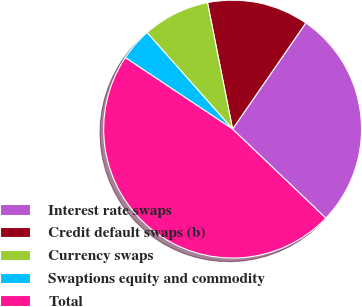Convert chart to OTSL. <chart><loc_0><loc_0><loc_500><loc_500><pie_chart><fcel>Interest rate swaps<fcel>Credit default swaps (b)<fcel>Currency swaps<fcel>Swaptions equity and commodity<fcel>Total<nl><fcel>27.52%<fcel>12.73%<fcel>8.42%<fcel>4.11%<fcel>47.21%<nl></chart> 